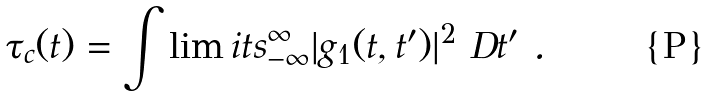Convert formula to latex. <formula><loc_0><loc_0><loc_500><loc_500>\tau _ { c } ( t ) = \int \lim i t s ^ { \infty } _ { - \infty } | g _ { 1 } ( t , t ^ { \prime } ) | ^ { 2 } \ D t ^ { \prime } \ .</formula> 